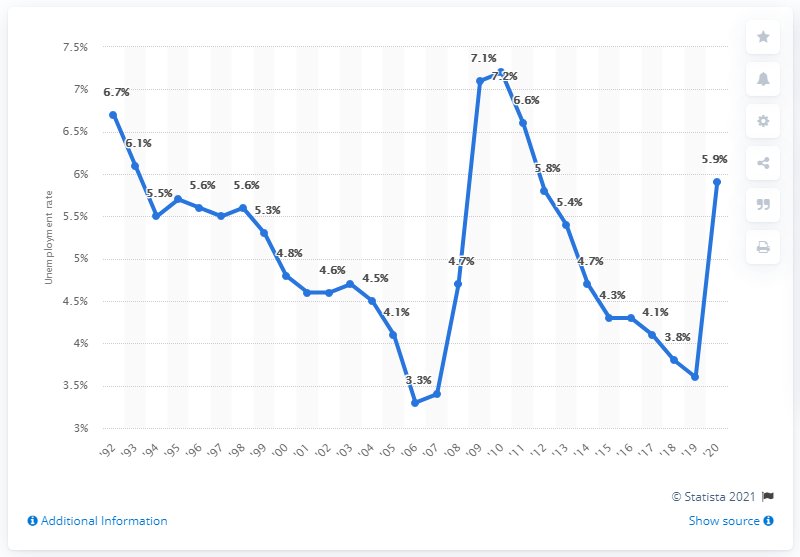Draw attention to some important aspects in this diagram. The unemployment rate in Montana in 2010 was 3.6%. Montana's highest unemployment rate in 2010 was 7.2%. The unemployment rate in Montana in 2020 was 5.9%. 